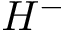<formula> <loc_0><loc_0><loc_500><loc_500>H ^ { - }</formula> 